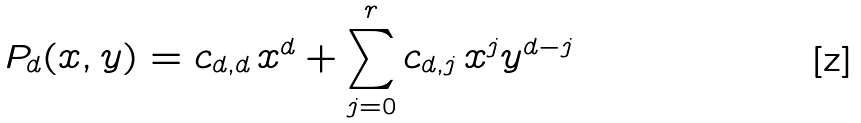<formula> <loc_0><loc_0><loc_500><loc_500>P _ { d } ( x , y ) = c _ { d , d } { \, } x ^ { d } + \sum _ { j = 0 } ^ { r } c _ { d , j } { \, } x ^ { j } y ^ { d - j }</formula> 